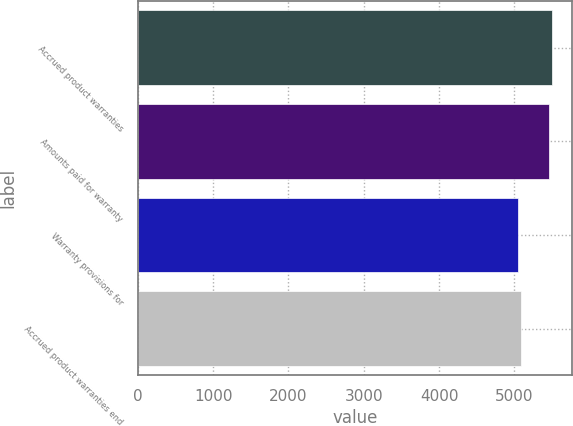<chart> <loc_0><loc_0><loc_500><loc_500><bar_chart><fcel>Accrued product warranties<fcel>Amounts paid for warranty<fcel>Warranty provisions for<fcel>Accrued product warranties end<nl><fcel>5495.7<fcel>5454<fcel>5048<fcel>5089.7<nl></chart> 